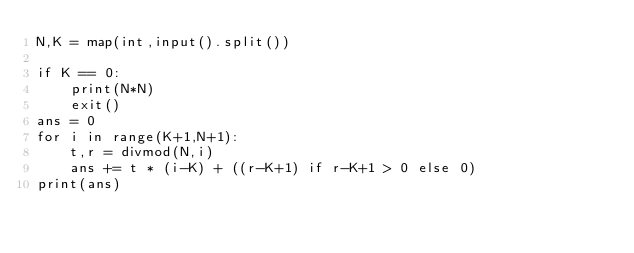<code> <loc_0><loc_0><loc_500><loc_500><_Python_>N,K = map(int,input().split())

if K == 0:
    print(N*N)
    exit()
ans = 0
for i in range(K+1,N+1):
    t,r = divmod(N,i)
    ans += t * (i-K) + ((r-K+1) if r-K+1 > 0 else 0)
print(ans)</code> 